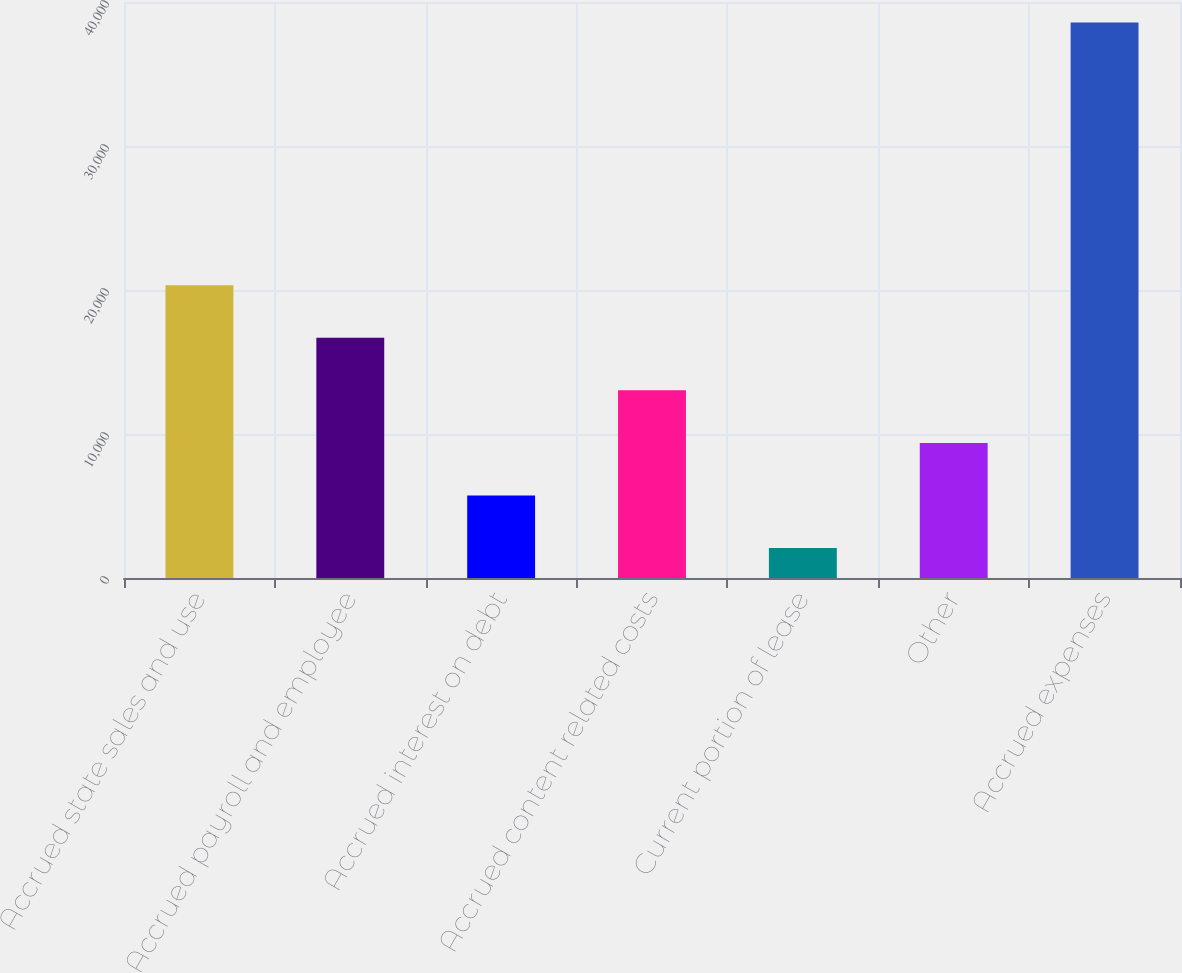<chart> <loc_0><loc_0><loc_500><loc_500><bar_chart><fcel>Accrued state sales and use<fcel>Accrued payroll and employee<fcel>Accrued interest on debt<fcel>Accrued content related costs<fcel>Current portion of lease<fcel>Other<fcel>Accrued expenses<nl><fcel>20327.5<fcel>16678.6<fcel>5731.9<fcel>13029.7<fcel>2083<fcel>9380.8<fcel>38572<nl></chart> 